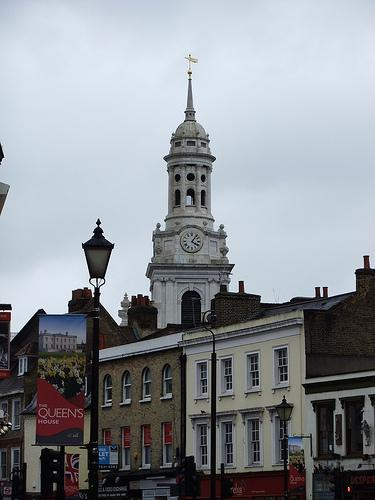Question: what is in the photo?
Choices:
A. A pyramid.
B. A tent.
C. A building.
D. A teepee.
Answer with the letter. Answer: C Question: what is on the building?
Choices:
A. A steeple.
B. A flag.
C. A clock.
D. An advertising inflatable.
Answer with the letter. Answer: C Question: who is in the photo?
Choices:
A. A man.
B. A woman.
C. Nobody.
D. A child.
Answer with the letter. Answer: C 